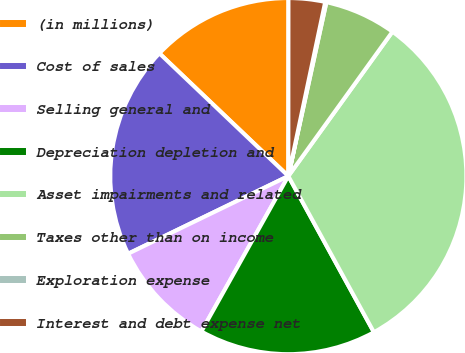Convert chart to OTSL. <chart><loc_0><loc_0><loc_500><loc_500><pie_chart><fcel>(in millions)<fcel>Cost of sales<fcel>Selling general and<fcel>Depreciation depletion and<fcel>Asset impairments and related<fcel>Taxes other than on income<fcel>Exploration expense<fcel>Interest and debt expense net<nl><fcel>12.9%<fcel>19.29%<fcel>9.7%<fcel>16.1%<fcel>32.08%<fcel>6.51%<fcel>0.11%<fcel>3.31%<nl></chart> 